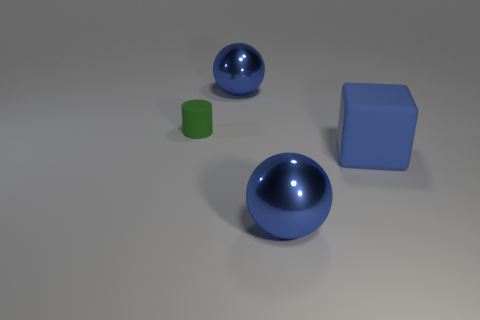Add 3 large blue metallic spheres. How many objects exist? 7 Subtract all small green rubber cylinders. Subtract all matte cubes. How many objects are left? 2 Add 3 small matte things. How many small matte things are left? 4 Add 4 rubber cubes. How many rubber cubes exist? 5 Subtract 0 brown balls. How many objects are left? 4 Subtract all cylinders. How many objects are left? 3 